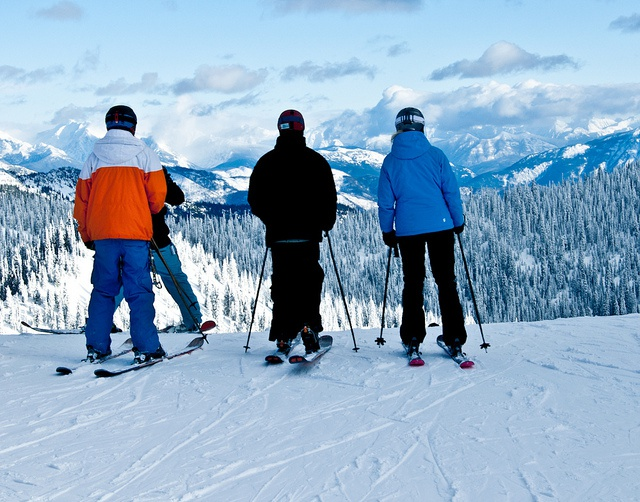Describe the objects in this image and their specific colors. I can see people in lightblue, navy, brown, and red tones, people in lightblue, blue, black, navy, and darkblue tones, people in lightblue, black, navy, blue, and white tones, people in lightblue, black, navy, and blue tones, and skis in lightblue, black, and navy tones in this image. 